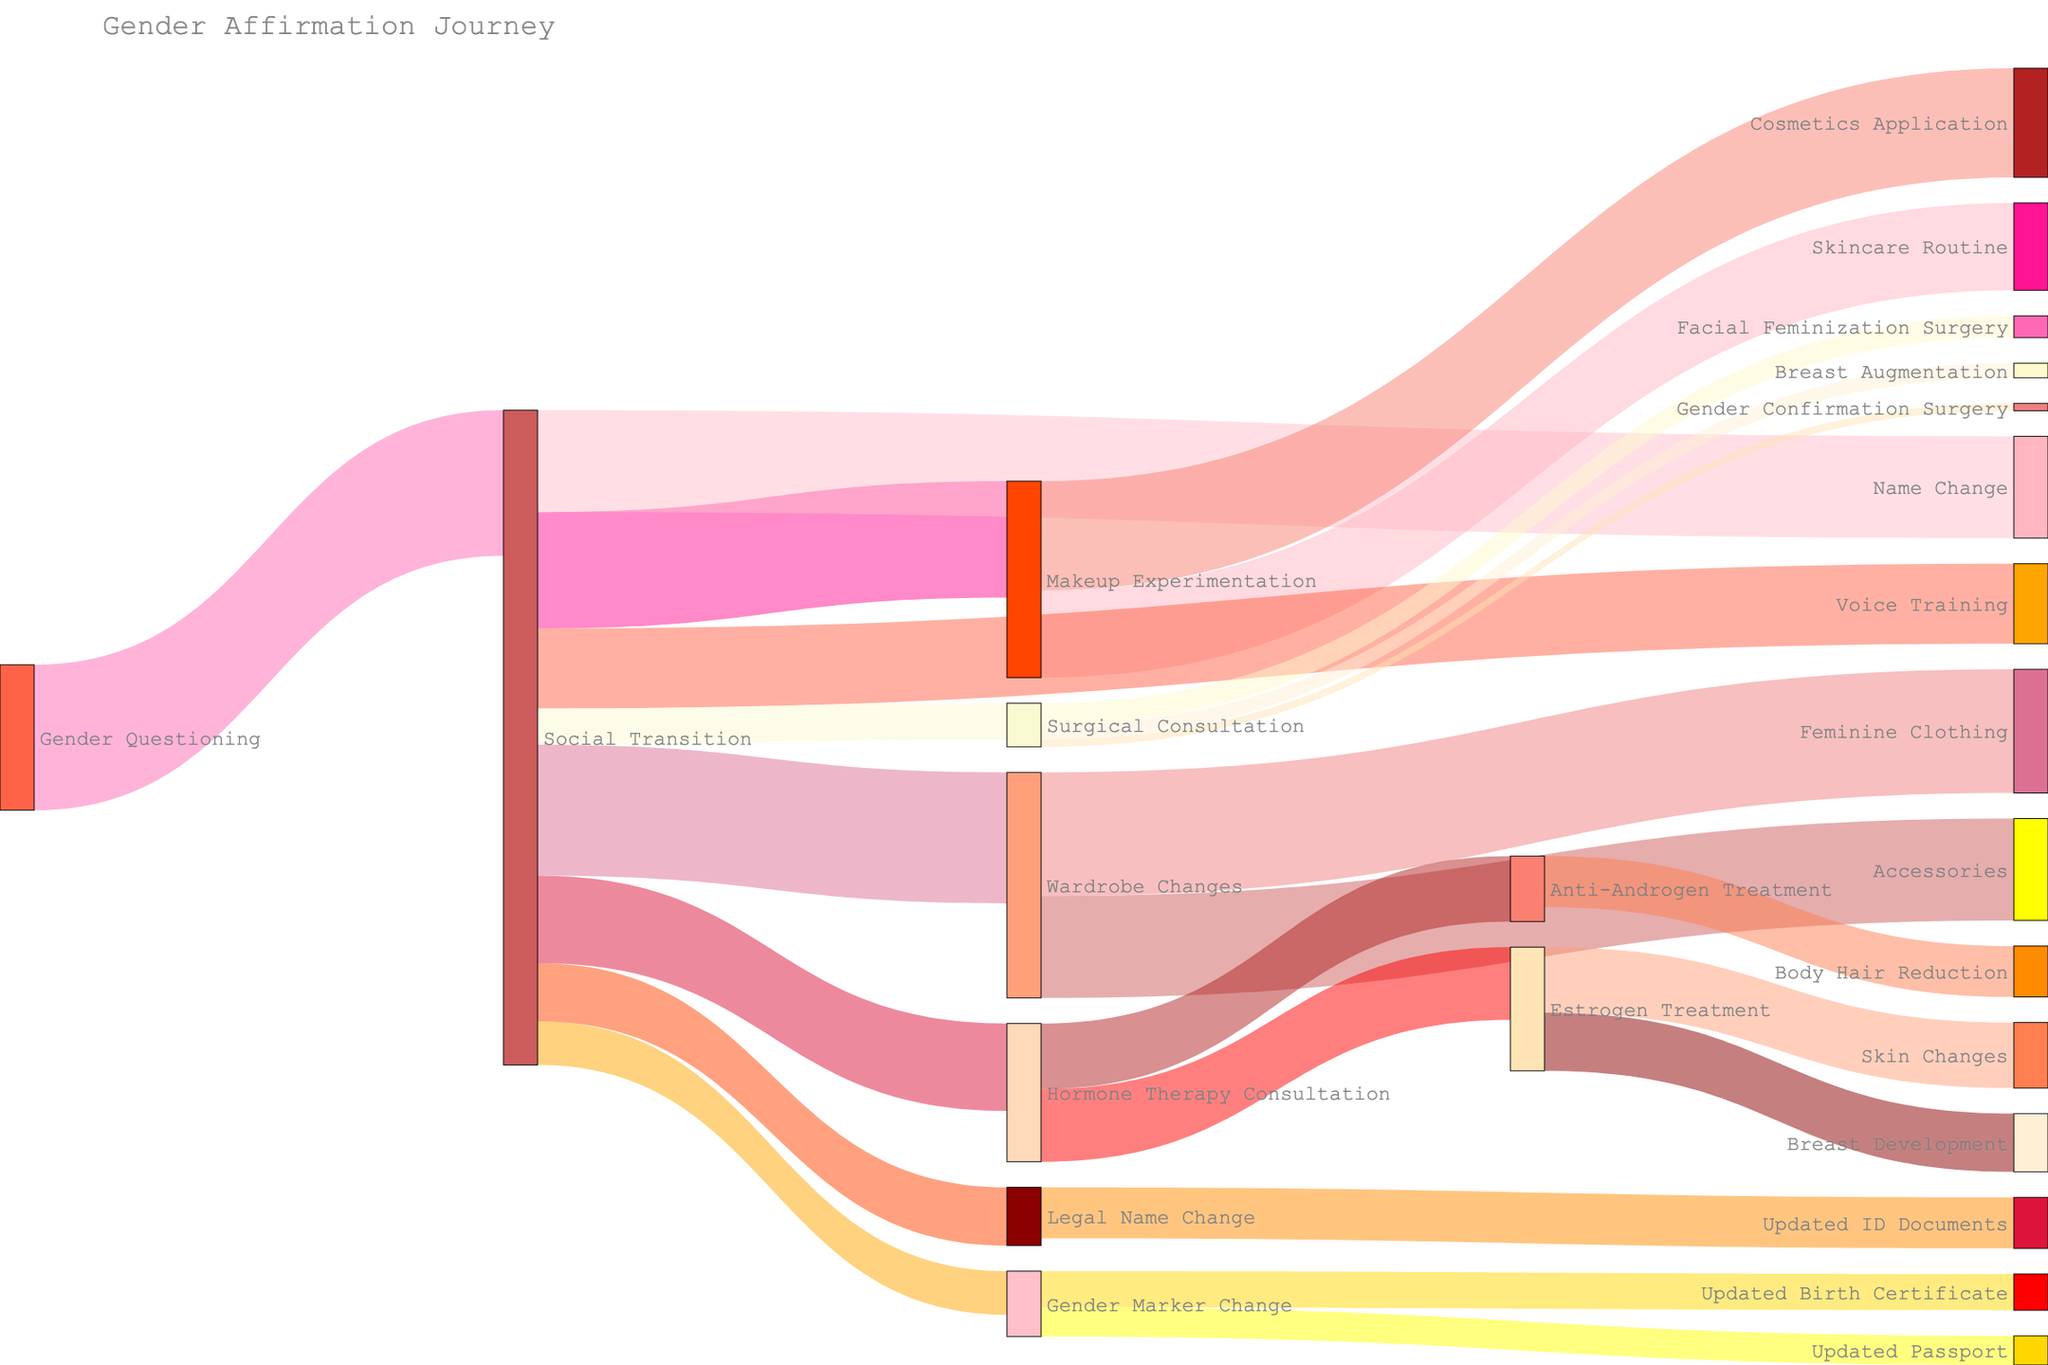What's the title of the Sankey Diagram? The title of the Sankey Diagram is usually displayed at the top of the figure. In this case, it is "Gender Affirmation Journey."
Answer: Gender Affirmation Journey Which step has the highest value starting from 'Social Transition'? To determine this, we look at the values associated with the branches originating from 'Social Transition.' The values are 80 (Makeup Experimentation), 90 (Wardrobe Changes), 70 (Name Change), 60 (Hormone Therapy Consultation), 55 (Voice Training), 40 (Legal Name Change), 30 (Gender Marker Change), and 25 (Surgical Consultation). The highest of these values is 90, corresponding to 'Wardrobe Changes.'
Answer: Wardrobe Changes How many steps are associated with 'Makeup Experimentation'? We need to count the number of targets connected to 'Makeup Experimentation.' They are 'Skincare Routine' and 'Cosmetics Application.' Thus, there are 2 steps.
Answer: 2 What is the total number of individuals involved in 'Gender Marker Change' related steps? The 'Gender Marker Change' leads to 'Updated Birth Certificate' (25) and 'Updated Passport' (20). Summing these values, 25 + 20 = 45.
Answer: 45 Which transition step has the lowest value from 'Hormone Therapy Consultation'? From 'Hormone Therapy Consultation,' the values are 50 (Estrogen Treatment) and 45 (Anti-Androgen Treatment). The lowest value is 45, which corresponds to 'Anti-Androgen Treatment.'
Answer: Anti-Androgen Treatment Compare the values of 'Facial Feminization Surgery' and 'Breast Augmentation.' Which is higher? The values for 'Facial Feminization Surgery' and 'Breast Augmentation' are 15 and 10, respectively. 'Facial Feminization Surgery' has a higher value.
Answer: Facial Feminization Surgery What percentage of the total value for 'Makeup Experimentation' leads to 'Cosmetics Application'? 'Makeup Experimentation' leads to 'Skincare Routine' (60) and 'Cosmetics Application' (75). The total value is 60 + 75 = 135. The percentage leading to 'Cosmetics Application' is (75/135) * 100 ≈ 55.56%.
Answer: 55.56% Identify the target step connected directly to both 'Hormone Therapy Consultation' and 'Surgical Consultation'. Looking at the branches, 'Estrogen Treatment' and 'Anti-Androgen Treatment' are connected to 'Hormone Therapy Consultation', while 'Facial Feminization Surgery,' 'Breast Augmentation,' and 'Gender Confirmation Surgery' are connected to 'Surgical Consultation.' There are no steps directly connected to both.
Answer: None What steps result in 'Updated ID Documents'? The step leading to 'Updated ID Documents' is 'Legal Name Change.'
Answer: Legal Name Change 